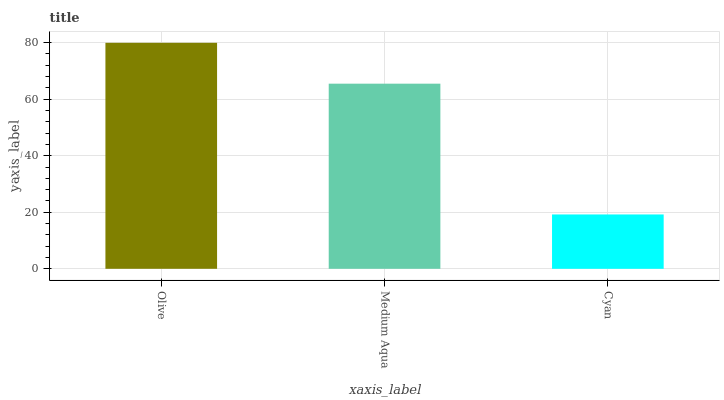Is Cyan the minimum?
Answer yes or no. Yes. Is Olive the maximum?
Answer yes or no. Yes. Is Medium Aqua the minimum?
Answer yes or no. No. Is Medium Aqua the maximum?
Answer yes or no. No. Is Olive greater than Medium Aqua?
Answer yes or no. Yes. Is Medium Aqua less than Olive?
Answer yes or no. Yes. Is Medium Aqua greater than Olive?
Answer yes or no. No. Is Olive less than Medium Aqua?
Answer yes or no. No. Is Medium Aqua the high median?
Answer yes or no. Yes. Is Medium Aqua the low median?
Answer yes or no. Yes. Is Cyan the high median?
Answer yes or no. No. Is Cyan the low median?
Answer yes or no. No. 